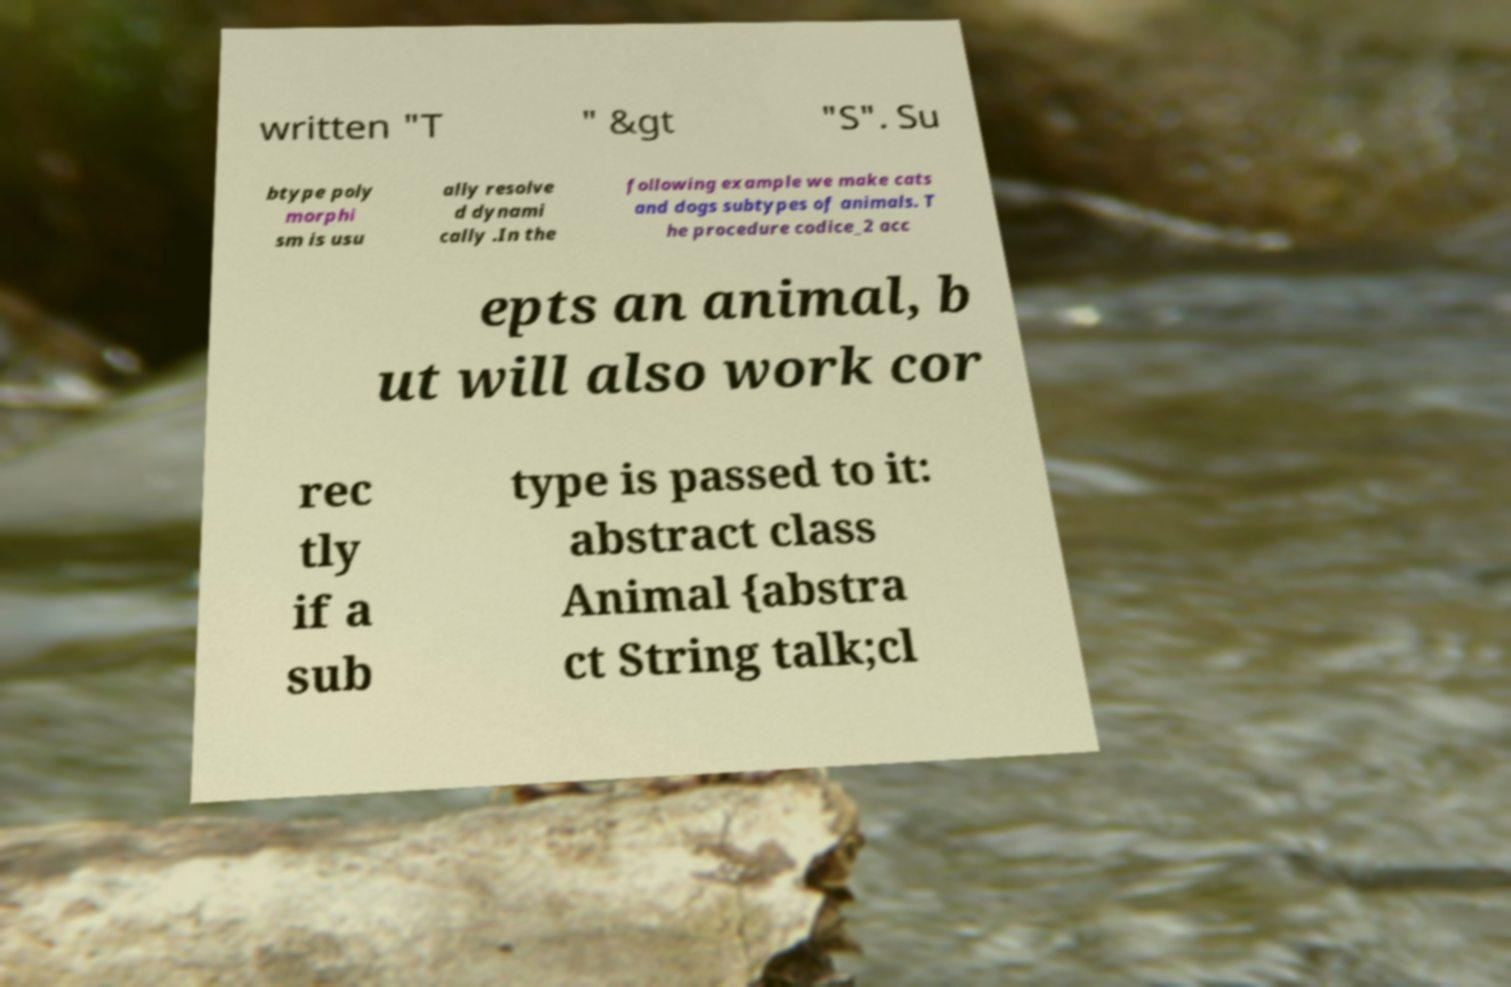There's text embedded in this image that I need extracted. Can you transcribe it verbatim? written "T " &gt "S". Su btype poly morphi sm is usu ally resolve d dynami cally .In the following example we make cats and dogs subtypes of animals. T he procedure codice_2 acc epts an animal, b ut will also work cor rec tly if a sub type is passed to it: abstract class Animal {abstra ct String talk;cl 